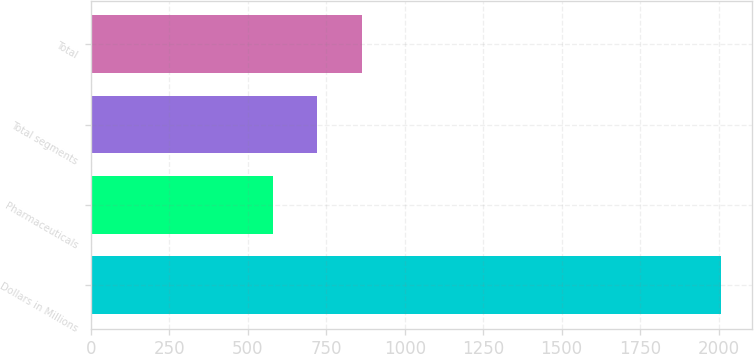Convert chart. <chart><loc_0><loc_0><loc_500><loc_500><bar_chart><fcel>Dollars in Millions<fcel>Pharmaceuticals<fcel>Total segments<fcel>Total<nl><fcel>2007<fcel>579<fcel>721.8<fcel>864.6<nl></chart> 